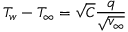Convert formula to latex. <formula><loc_0><loc_0><loc_500><loc_500>T _ { w } - T _ { \infty } = \sqrt { C } \frac { q } { \sqrt { v _ { \infty } } }</formula> 